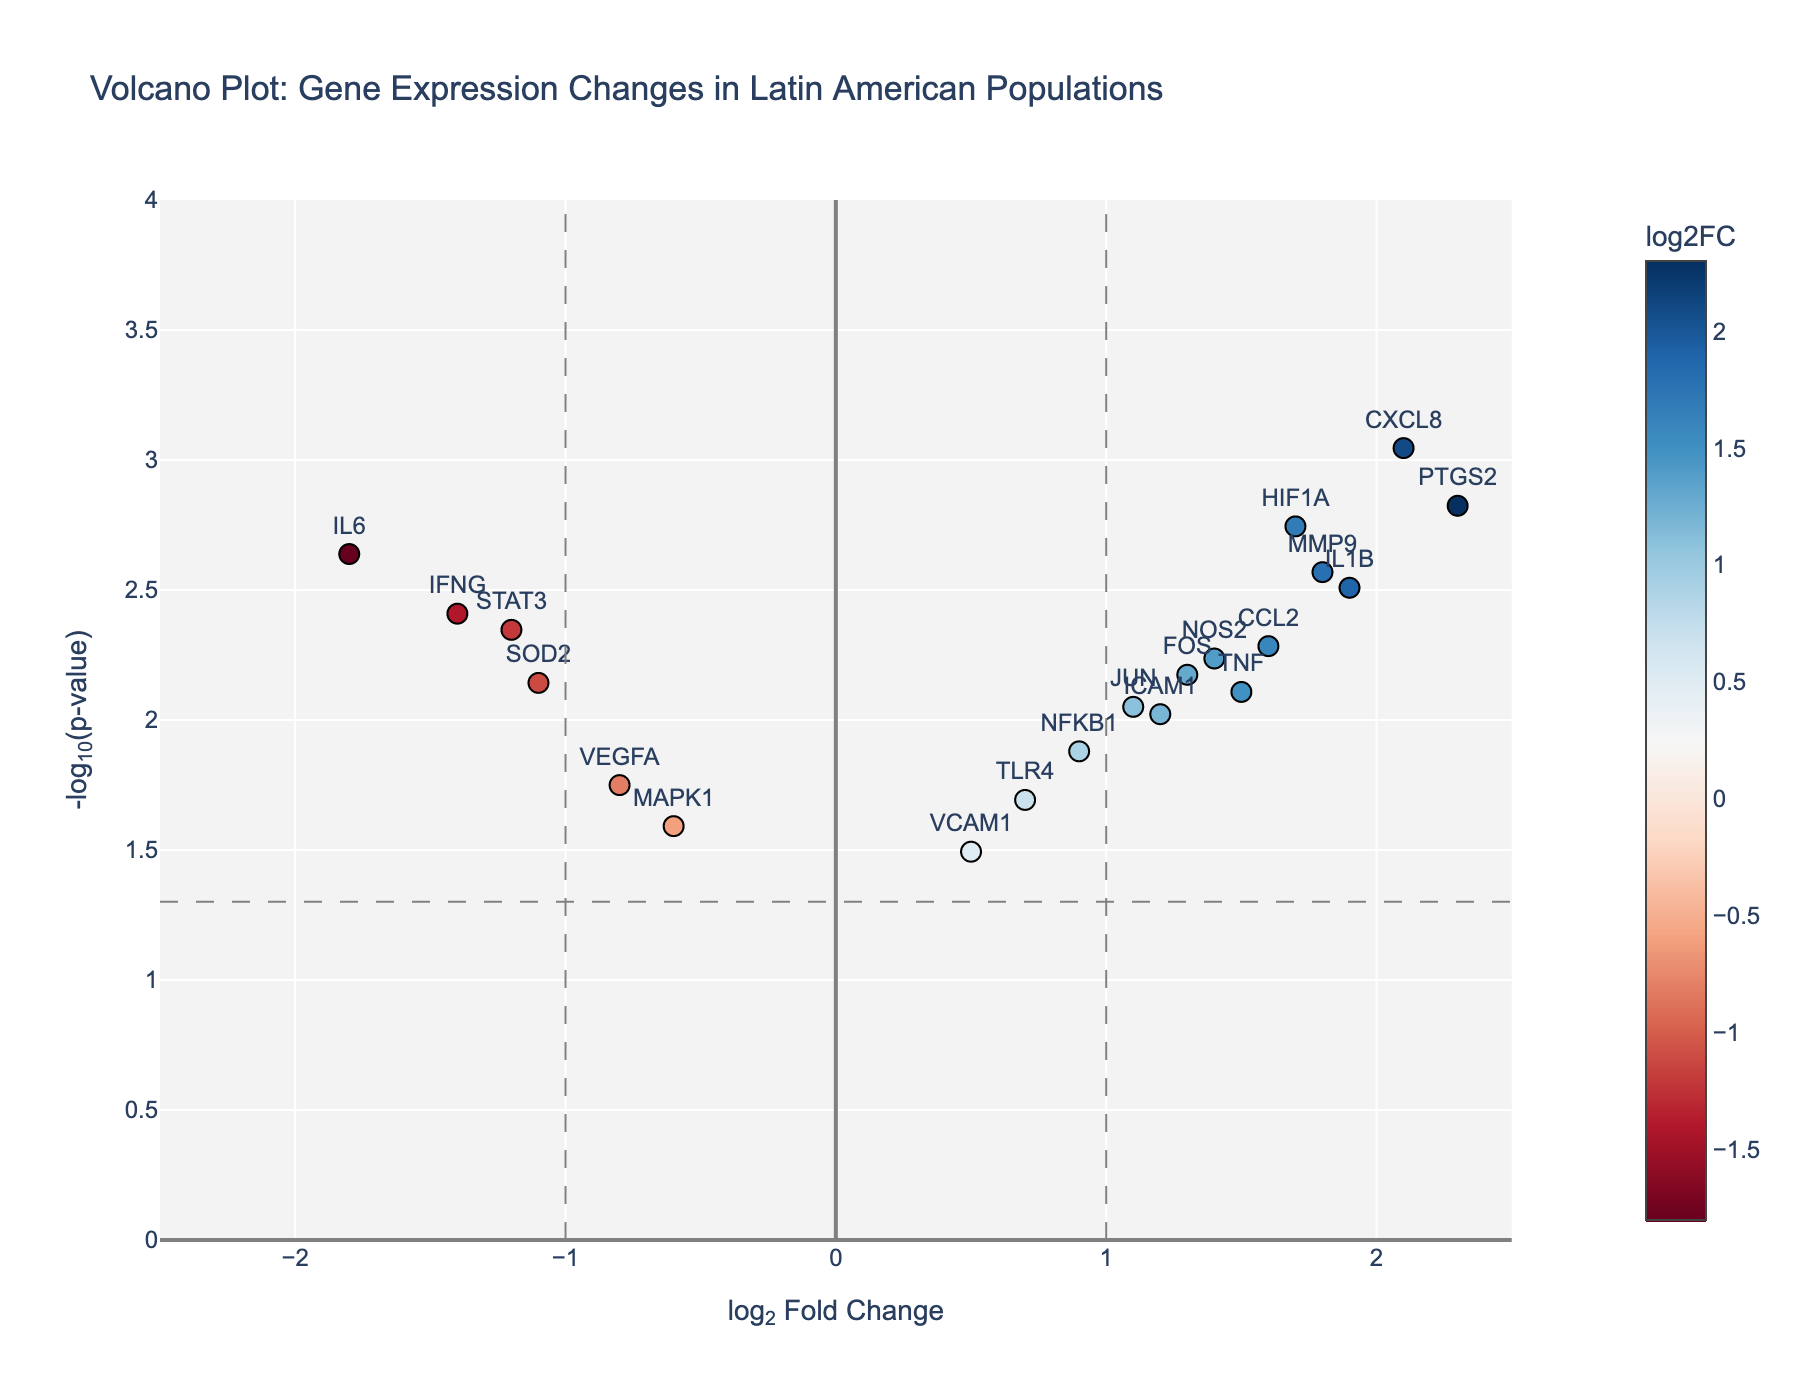How many data points are above -log10(p-value) = 3? Given that the horizontal grid line at -log10(p-value) = 3 intersects the y-axis at that value, count the genes plotted above this line. These points have a -log10(p-value) higher than 3. Visual inspection shows there are 6 points visible above this line.
Answer: 6 Which gene has the highest -log10(p-value)? The highest -log10(p-value) corresponds to the top-most data point on the plot. This point is labeled "CXCL8" and is positioned above all other points.
Answer: CXCL8 How many genes have a log2FoldChange greater than 1 and a -log10(p-value) greater than 2? Look for points in the top right quadrant where the x-value (log2FoldChange) is greater than 1 and the y-value (-log10(p-value)) is greater than 2. Count the number of points in this region. There are 5 such data points: PTGS2, IL1B, IFNG, CCL2, and HIF1A.
Answer: 5 What is the color range of the genes on the plot? The color of the points represents the log2FoldChange, with a color bar indicating the range from blue to red. The color bar minimum value is around -1.4 (blue) and the maximum value is approximately 2.3 (red).
Answer: Blue to Red Which gene has the smallest log2FoldChange but a significant p-value (p-value < 0.05)? Focus on the genes on the left side of the plot (small log2FoldChange values). Among these, identify the points above the horizontal dashed line (-log10(p-value) of 0.05). The gene "MAPK1" has the smallest log2FoldChange (-0.6) within this significance threshold.
Answer: MAPK1 Compare the log2FoldChange of TNF and IL6. Which one has a higher value and by how much? Locate both genes on the plot and read their log2FoldChange values. TNF has a log2FoldChange of 1.5 and IL6 has -1.8. The difference is 1.5 - (-1.8) = 3.3.
Answer: TNF, by 3.3 Determine if any genes have both a log2FoldChange less than -1 and a p-value less than 0.01. Look at the genes on the left side of the plot with log2FoldChange less than -1. Confirm if they lie above the horizontal line representing a -log10(p-value) of 0.01. Only IL6 meets both criteria.
Answer: Yes, IL6 What percentage of genes have a -log10(p-value) greater than 1.5? Count the number of genes above -log10(p-value) = 1.5 and divide by the total number of genes (20). There are 12 genes above this threshold. 12/20 = 0.6, then multiply by 100 to convert to percentage.
Answer: 60% Which gene with a positive log2FoldChange has the highest p-value (smallest -log10(p-value))? Among genes with positive log2FoldChange (right of the center line), find the one with the lowest y-axis value (smallest -log10(p-value)). VCAM1 has the highest p-value in this group.
Answer: VCAM1 